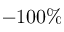<formula> <loc_0><loc_0><loc_500><loc_500>- 1 0 0 \%</formula> 